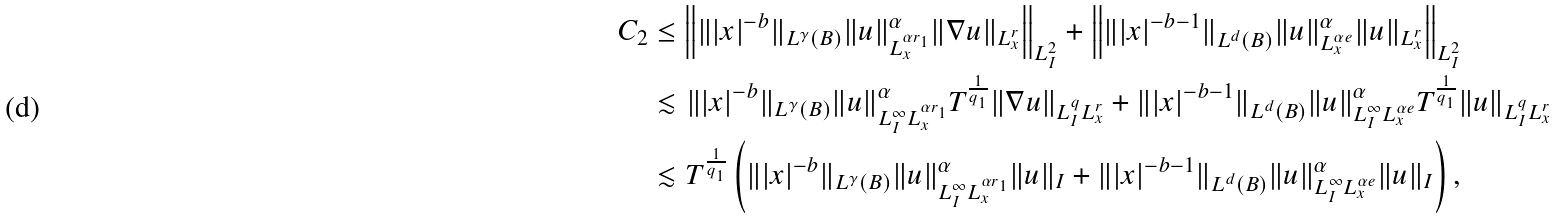Convert formula to latex. <formula><loc_0><loc_0><loc_500><loc_500>C _ { 2 } & \leq \left \| \| | x | ^ { - b } \| _ { L ^ { \gamma } ( B ) } \| u \| ^ { \alpha } _ { L _ { x } ^ { \alpha r _ { 1 } } } \| \nabla u \| _ { L _ { x } ^ { r } } \right \| _ { L ^ { 2 } _ { I } } + \left \| \| | x | ^ { - b - 1 } \| _ { L ^ { d } ( B ) } \| u \| ^ { \alpha } _ { L ^ { \alpha e } _ { x } } \| u \| _ { L ^ { r } _ { x } } \right \| _ { L ^ { 2 } _ { I } } \\ & \lesssim \| | x | ^ { - b } \| _ { L ^ { \gamma } ( B ) } \| u \| ^ { \alpha } _ { L ^ { \infty } _ { I } L _ { x } ^ { \alpha r _ { 1 } } } T ^ { \frac { 1 } { q _ { 1 } } } \| \nabla u \| _ { L ^ { q } _ { I } L _ { x } ^ { r } } + \| | x | ^ { - b - 1 } \| _ { L ^ { d } ( B ) } \| u \| ^ { \alpha } _ { L ^ { \infty } _ { I } L ^ { \alpha e } _ { x } } T ^ { \frac { 1 } { q _ { 1 } } } \| u \| _ { L ^ { q } _ { I } L ^ { r } _ { x } } \\ & \lesssim T ^ { \frac { 1 } { q _ { 1 } } } \left ( \| | x | ^ { - b } \| _ { L ^ { \gamma } ( B ) } \| u \| ^ { \alpha } _ { L ^ { \infty } _ { I } L _ { x } ^ { \alpha r _ { 1 } } } \| u \| _ { I } + \| | x | ^ { - b - 1 } \| _ { L ^ { d } ( B ) } \| u \| ^ { \alpha } _ { L ^ { \infty } _ { I } L ^ { \alpha e } _ { x } } \| u \| _ { I } \right ) ,</formula> 